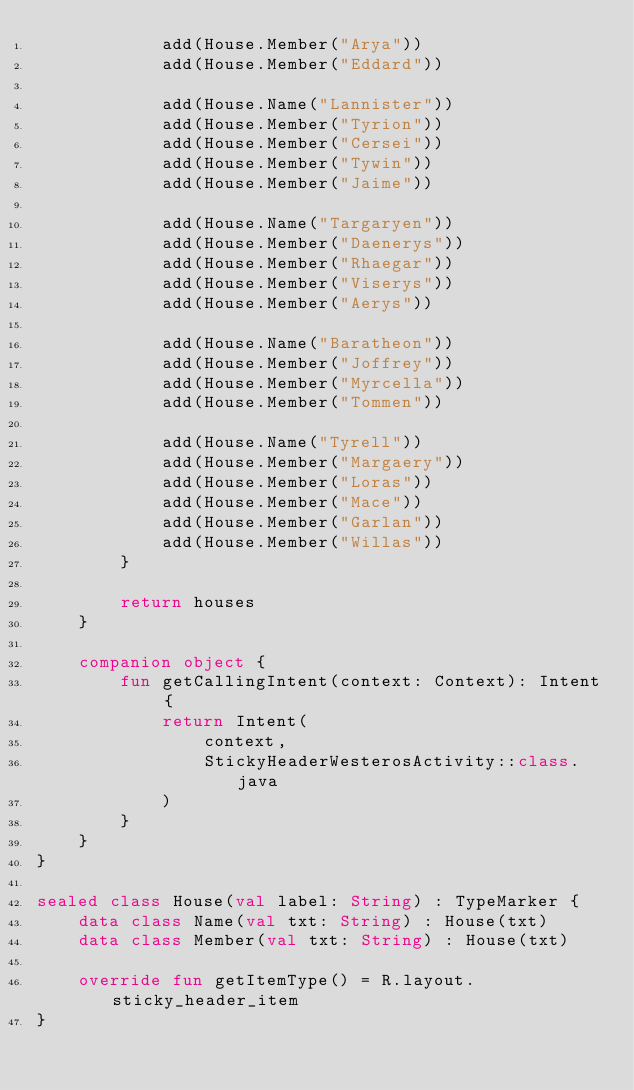Convert code to text. <code><loc_0><loc_0><loc_500><loc_500><_Kotlin_>            add(House.Member("Arya"))
            add(House.Member("Eddard"))

            add(House.Name("Lannister"))
            add(House.Member("Tyrion"))
            add(House.Member("Cersei"))
            add(House.Member("Tywin"))
            add(House.Member("Jaime"))

            add(House.Name("Targaryen"))
            add(House.Member("Daenerys"))
            add(House.Member("Rhaegar"))
            add(House.Member("Viserys"))
            add(House.Member("Aerys"))

            add(House.Name("Baratheon"))
            add(House.Member("Joffrey"))
            add(House.Member("Myrcella"))
            add(House.Member("Tommen"))

            add(House.Name("Tyrell"))
            add(House.Member("Margaery"))
            add(House.Member("Loras"))
            add(House.Member("Mace"))
            add(House.Member("Garlan"))
            add(House.Member("Willas"))
        }

        return houses
    }

    companion object {
        fun getCallingIntent(context: Context): Intent {
            return Intent(
                context,
                StickyHeaderWesterosActivity::class.java
            )
        }
    }
}

sealed class House(val label: String) : TypeMarker {
    data class Name(val txt: String) : House(txt)
    data class Member(val txt: String) : House(txt)

    override fun getItemType() = R.layout.sticky_header_item
}</code> 